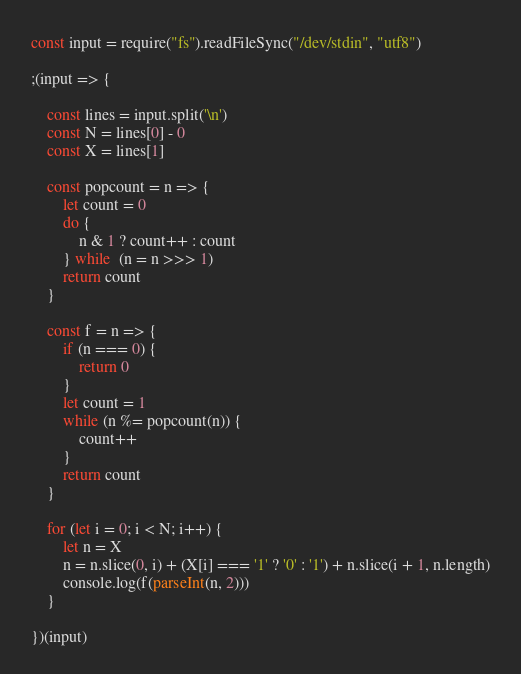<code> <loc_0><loc_0><loc_500><loc_500><_JavaScript_>const input = require("fs").readFileSync("/dev/stdin", "utf8")

;(input => {

    const lines = input.split('\n')
    const N = lines[0] - 0
    const X = lines[1]

    const popcount = n => {
        let count = 0
        do {
            n & 1 ? count++ : count
        } while  (n = n >>> 1)
        return count
    }

    const f = n => {
        if (n === 0) {
            return 0
        }
        let count = 1
        while (n %= popcount(n)) {
            count++
        }
        return count
    }

    for (let i = 0; i < N; i++) {
        let n = X
        n = n.slice(0, i) + (X[i] === '1' ? '0' : '1') + n.slice(i + 1, n.length)
        console.log(f(parseInt(n, 2)))
    }

})(input)
</code> 